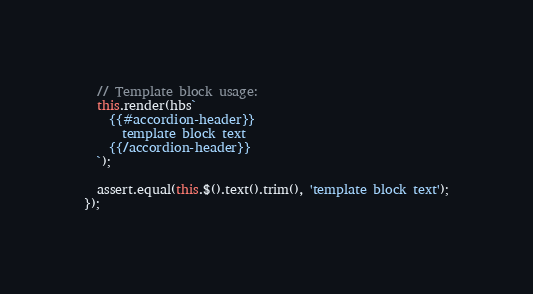Convert code to text. <code><loc_0><loc_0><loc_500><loc_500><_JavaScript_>  // Template block usage:
  this.render(hbs`
    {{#accordion-header}}
      template block text
    {{/accordion-header}}
  `);

  assert.equal(this.$().text().trim(), 'template block text');
});
</code> 